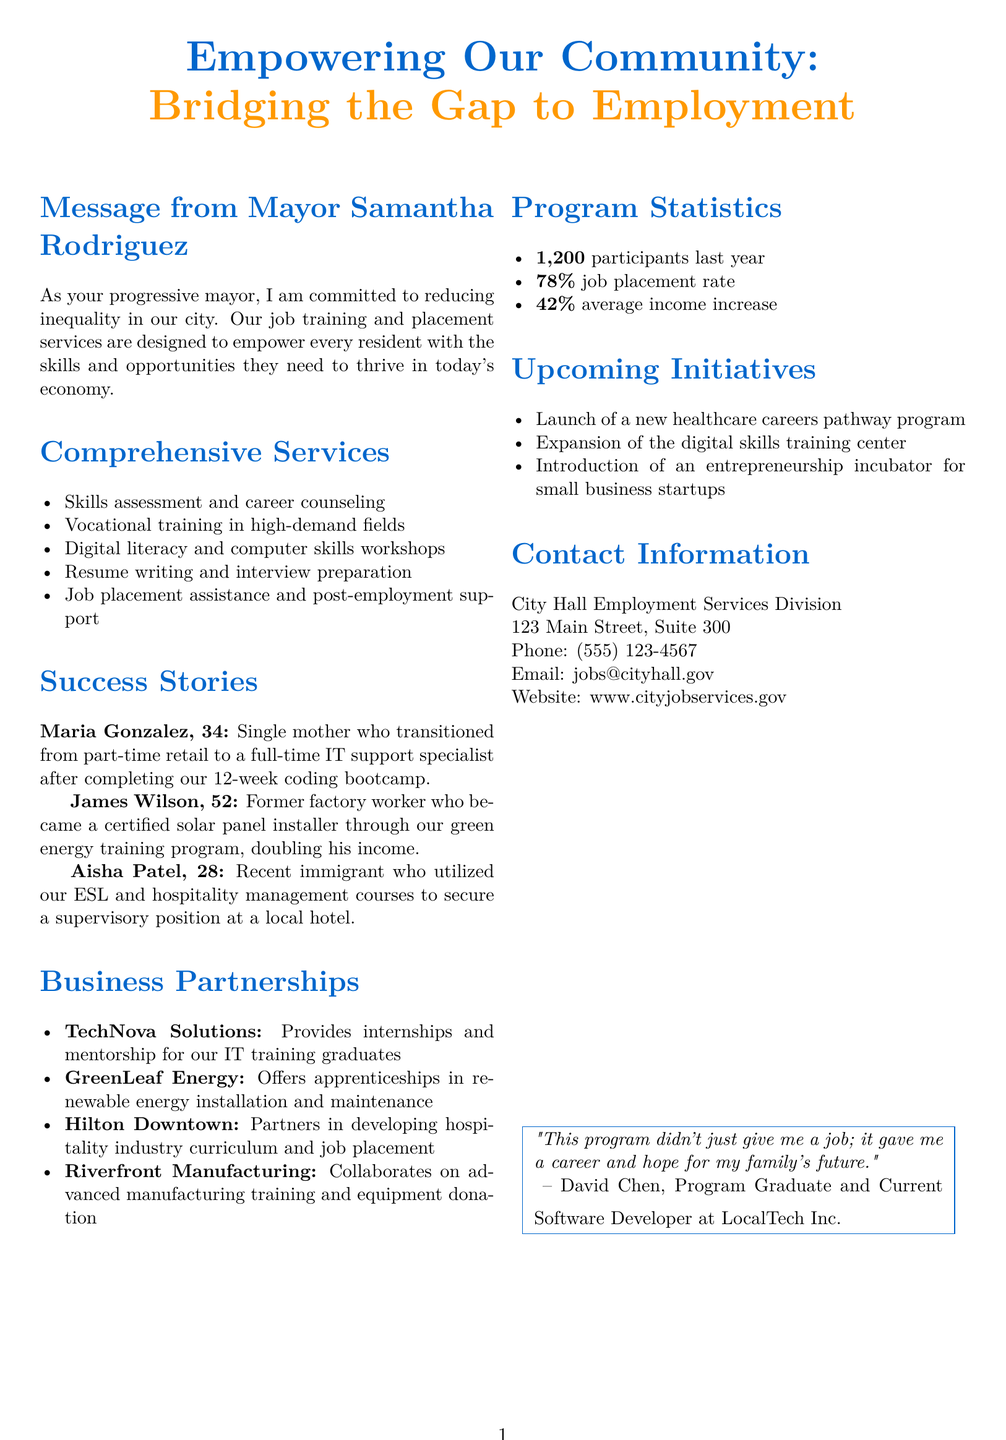What is the title of the brochure? The title of the brochure is prominently displayed at the top, stating its purpose to empower the community.
Answer: Empowering Our Community: Bridging the Gap to Employment Who is the mayor mentioned in the document? The mayor is mentioned in the message section of the brochure, focusing on her commitment to reducing inequality in the city.
Answer: Samantha Rodriguez How many participants were there last year? The document includes a statistic about the number of participants in the job training program last year.
Answer: 1200 What is the job placement rate mentioned? This statistic highlights the effectiveness of the job placement services offered in the program.
Answer: 78% Name one company that provides internships for IT graduates. This company is listed under the business partnerships section, demonstrating local business involvement in the program.
Answer: TechNova Solutions What was Maria Gonzalez's previous job? Maria's story provides insight into her career transition, starting from a part-time position before joining the program.
Answer: Part-time retail What kind of training did James Wilson complete? This information is found in James's success story, reflecting the program's diverse training offerings.
Answer: Green energy training Which initiative is set to launch next? The upcoming initiatives section lists future programs scheduled for implementation in the community.
Answer: Healthcare careers pathway program 